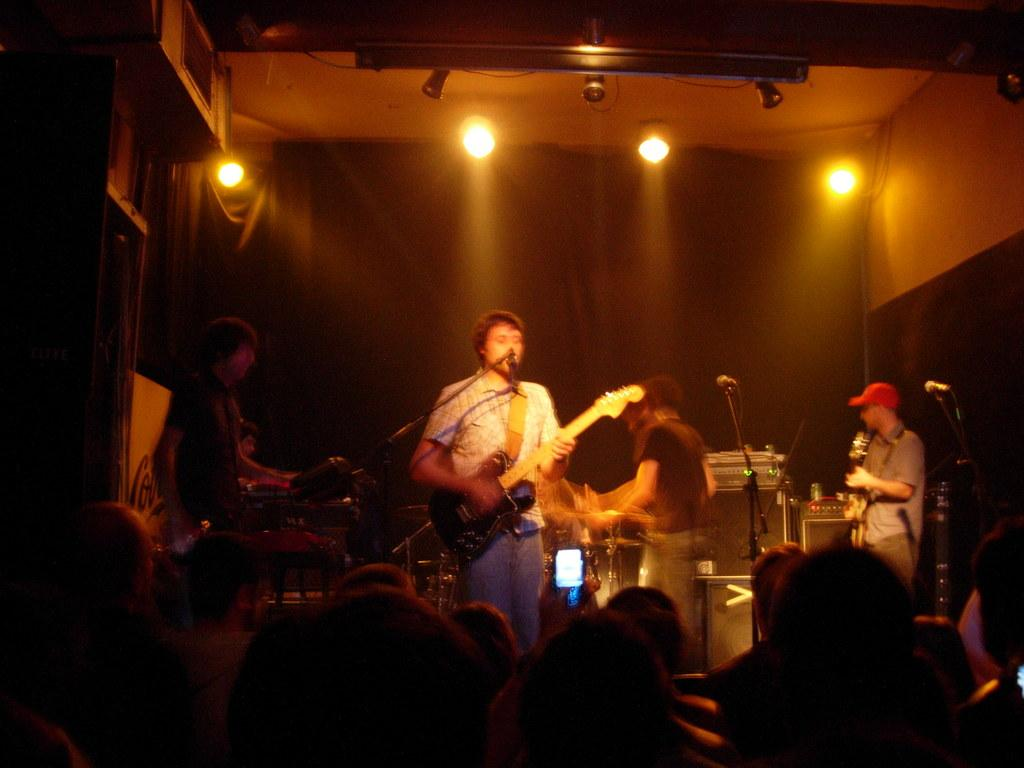Who is the main subject in the image? There is a man in the image. Where is the man located in the image? The man is standing in the middle of the image. What is the man doing in the image? The man is playing the guitar. What can be seen at the top of the image? There are lights visible at the top of the image. What type of glue is the man using to play the guitar in the image? There is no glue present in the image, and the man is not using any glue to play the guitar. 